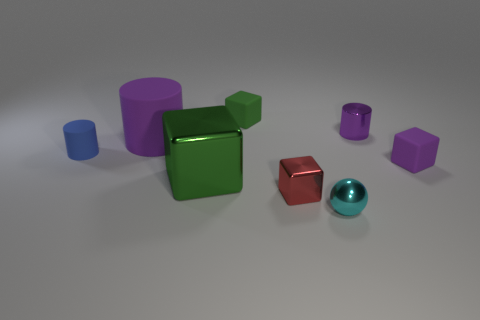Is there any other thing that is made of the same material as the tiny ball?
Offer a terse response. Yes. There is a small green object; are there any small red shiny cubes behind it?
Your answer should be compact. No. How many small green objects are there?
Keep it short and to the point. 1. How many red metallic objects are in front of the cube to the right of the tiny red thing?
Provide a short and direct response. 1. Do the big matte cylinder and the tiny block that is to the right of the tiny metal ball have the same color?
Your answer should be compact. Yes. What number of blue matte objects are the same shape as the tiny purple matte object?
Offer a terse response. 0. There is a purple thing in front of the large rubber object; what material is it?
Offer a very short reply. Rubber. There is a small shiny thing that is to the right of the sphere; is it the same shape as the red metallic object?
Your answer should be very brief. No. Is there a matte sphere of the same size as the purple shiny cylinder?
Ensure brevity in your answer.  No. There is a red metallic object; does it have the same shape as the tiny metallic object behind the small blue matte object?
Your answer should be compact. No. 